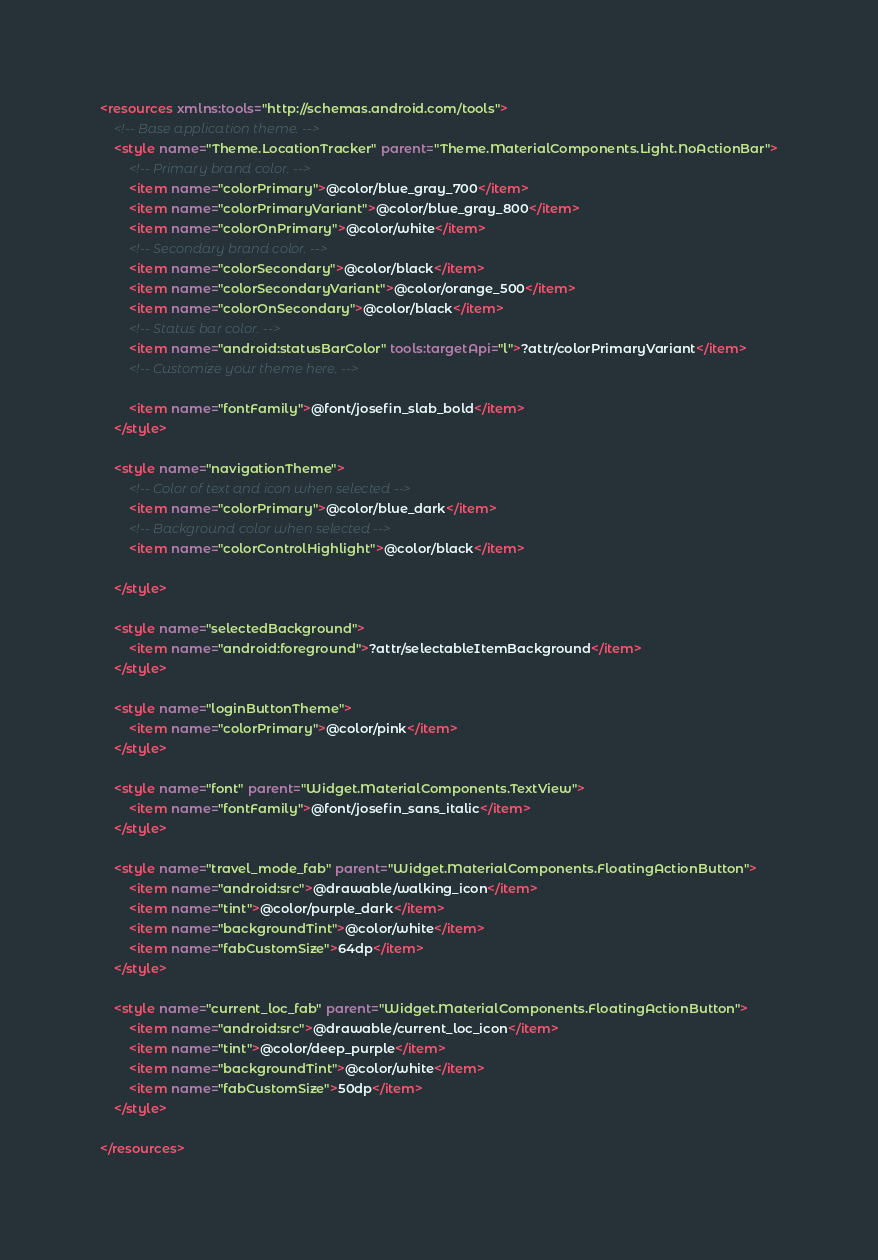Convert code to text. <code><loc_0><loc_0><loc_500><loc_500><_XML_><resources xmlns:tools="http://schemas.android.com/tools">
    <!-- Base application theme. -->
    <style name="Theme.LocationTracker" parent="Theme.MaterialComponents.Light.NoActionBar">
        <!-- Primary brand color. -->
        <item name="colorPrimary">@color/blue_gray_700</item>
        <item name="colorPrimaryVariant">@color/blue_gray_800</item>
        <item name="colorOnPrimary">@color/white</item>
        <!-- Secondary brand color. -->
        <item name="colorSecondary">@color/black</item>
        <item name="colorSecondaryVariant">@color/orange_500</item>
        <item name="colorOnSecondary">@color/black</item>
        <!-- Status bar color. -->
        <item name="android:statusBarColor" tools:targetApi="l">?attr/colorPrimaryVariant</item>
        <!-- Customize your theme here. -->

        <item name="fontFamily">@font/josefin_slab_bold</item>
    </style>

    <style name="navigationTheme">
        <!-- Color of text and icon when selected -->
        <item name="colorPrimary">@color/blue_dark</item>
        <!-- Background color when selected -->
        <item name="colorControlHighlight">@color/black</item>

    </style>

    <style name="selectedBackground">
        <item name="android:foreground">?attr/selectableItemBackground</item>
    </style>

    <style name="loginButtonTheme">
        <item name="colorPrimary">@color/pink</item>
    </style>

    <style name="font" parent="Widget.MaterialComponents.TextView">
        <item name="fontFamily">@font/josefin_sans_italic</item>
    </style>

    <style name="travel_mode_fab" parent="Widget.MaterialComponents.FloatingActionButton">
        <item name="android:src">@drawable/walking_icon</item>
        <item name="tint">@color/purple_dark</item>
        <item name="backgroundTint">@color/white</item>
        <item name="fabCustomSize">64dp</item>
    </style>

    <style name="current_loc_fab" parent="Widget.MaterialComponents.FloatingActionButton">
        <item name="android:src">@drawable/current_loc_icon</item>
        <item name="tint">@color/deep_purple</item>
        <item name="backgroundTint">@color/white</item>
        <item name="fabCustomSize">50dp</item>
    </style>

</resources></code> 